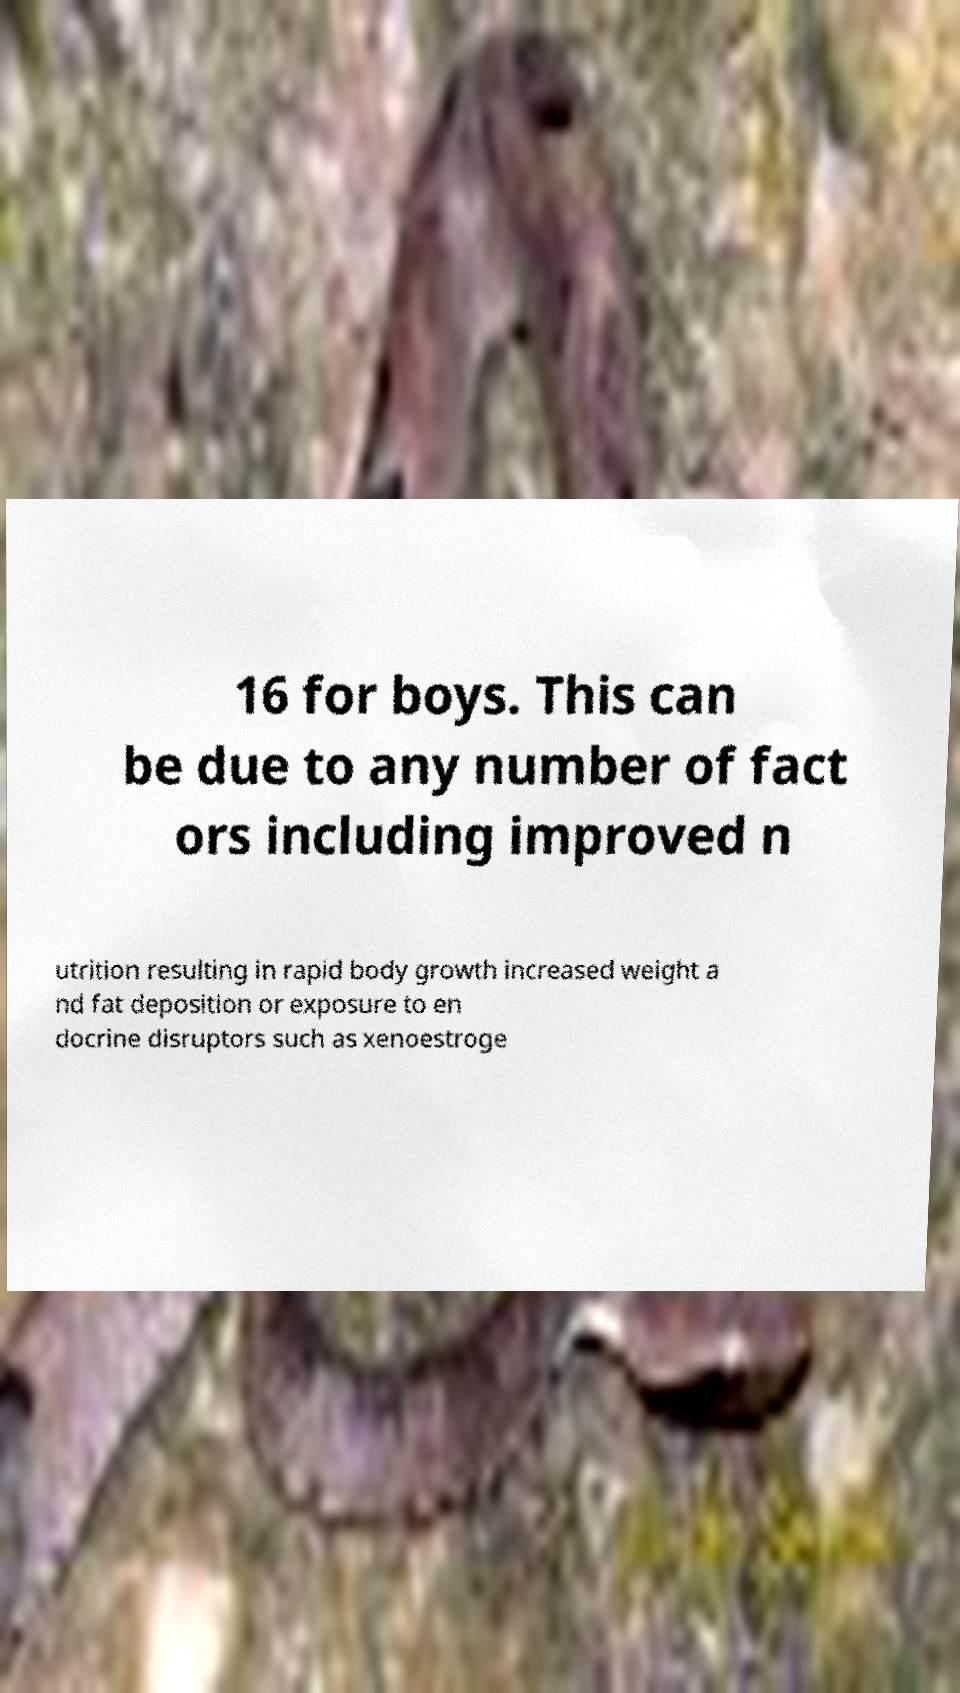Can you accurately transcribe the text from the provided image for me? 16 for boys. This can be due to any number of fact ors including improved n utrition resulting in rapid body growth increased weight a nd fat deposition or exposure to en docrine disruptors such as xenoestroge 